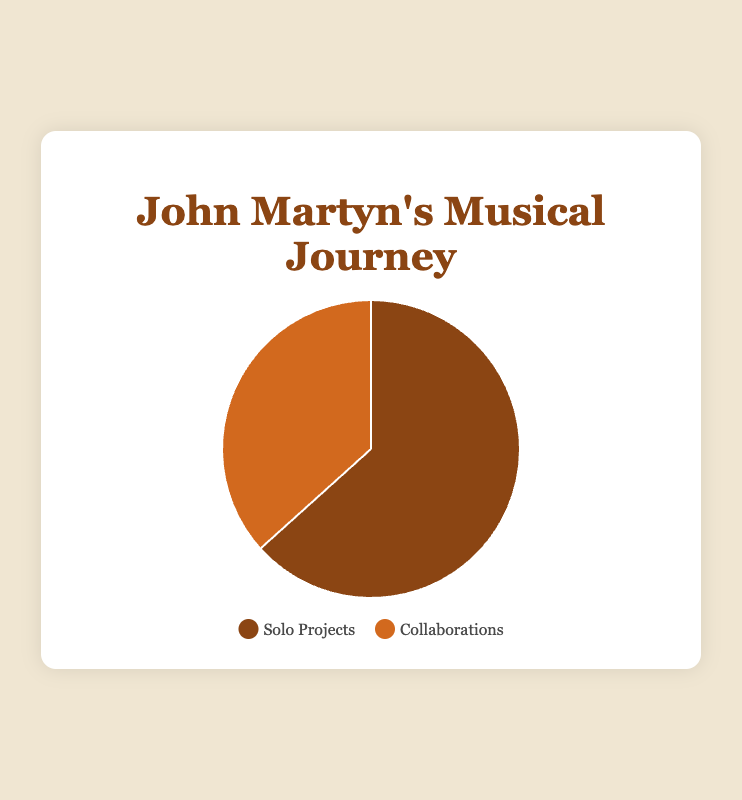Which project type has the higher count? The pie chart shows the count of "Solo Projects" and "Collaborations". The "Solo Projects" section appears larger. Thus, "Solo Projects" have a higher count.
Answer: Solo Projects What is the difference in the number of projects between solo projects and collaborations? The pie chart data indicates that there are 19 solo projects and 11 collaborations. The difference is calculated as 19 - 11.
Answer: 8 What percentage of John Martyn's total projects are solo projects? There are 19 solo projects and 11 collaborations, making the total number of projects 30. The percentage of solo projects is calculated as (19 / 30) * 100.
Answer: Approximately 63.3% By what factor do solo projects outnumber collaborations? To determine the factor by which solo projects outnumber collaborations, divide the number of solo projects by the number of collaborations: 19 / 11.
Answer: Approximately 1.73 How many total projects did John Martyn work on during his career? The pie chart shows the counts for solo projects and collaborations, which are 19 and 11 respectively. Summing these values gives the total number of projects: 19 + 11.
Answer: 30 What is the ratio of solo projects to collaborations? The chart indicates 19 solo projects and 11 collaborations. This ratio is expressed as 19:11.
Answer: 19:11 Which project type is represented by the brown color in the chart? According to the legend accompanying the pie chart, the brown color represents solo projects.
Answer: Solo Projects By how much percentage do solo projects exceed collaborations? The percentage difference is calculated as ((19 - 11) / 11) * 100, reflecting the amount by which solo projects exceed collaborations in percentage terms.
Answer: Approximately 72.7% 